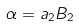<formula> <loc_0><loc_0><loc_500><loc_500>\alpha = a _ { 2 } B _ { 2 }</formula> 